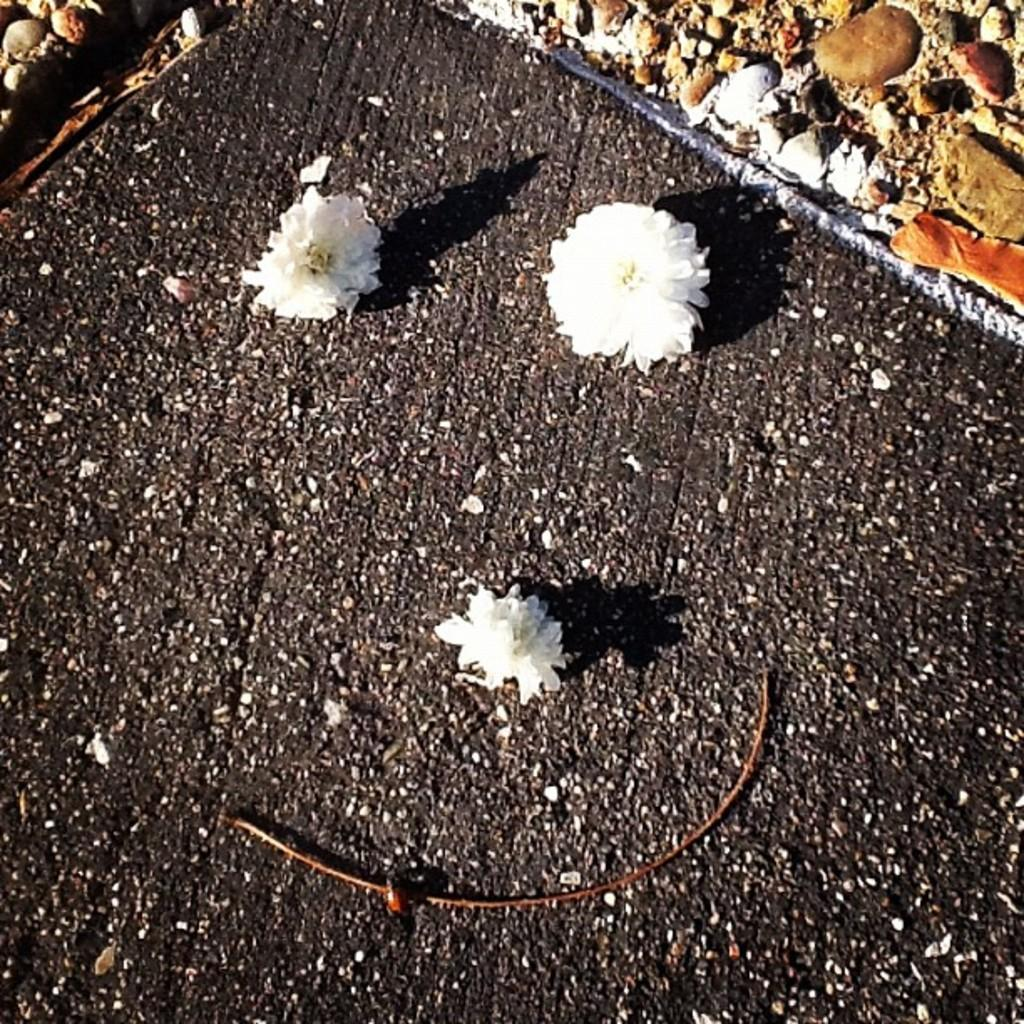How many flowers can be seen in the image? There are three white flowers in the image. What else is visible in the image besides the flowers? There are stones visible in the image. What type of cherry is being used to light the flame in the image? There is no cherry or flame present in the image; it only features three white flowers and stones. 